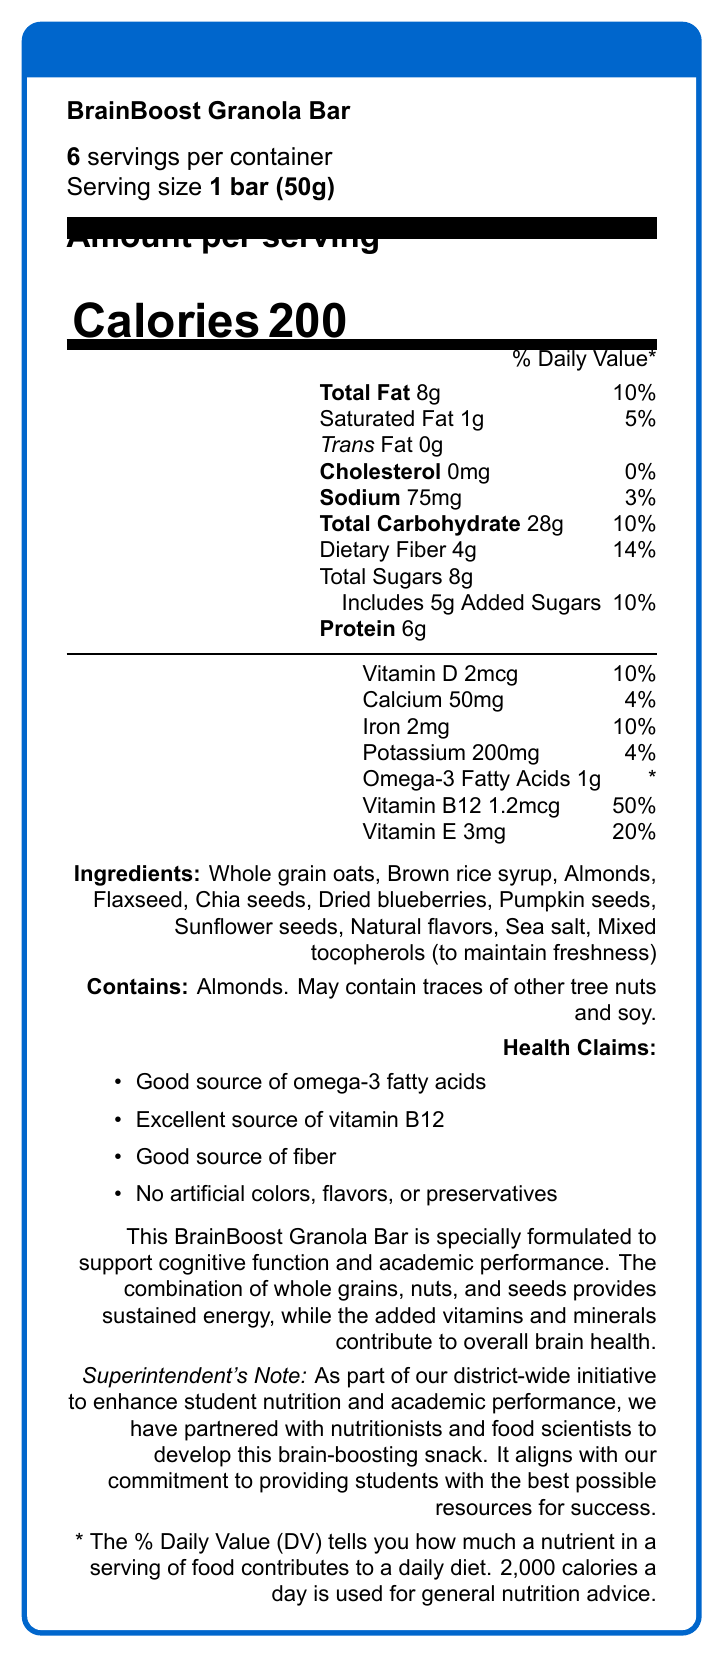What is the serving size for BrainBoost Granola Bar? The serving size is explicitly mentioned as "1 bar (50g)" in the document.
Answer: 1 bar (50g) How many calories are there per serving of the BrainBoost Granola Bar? The document clearly states that there are 200 calories per serving.
Answer: 200 What percentage of the Daily Value for vitamin B12 does one bar provide? The document lists Vitamin B12 as providing 50% of the Daily Value per serving.
Answer: 50% Does the BrainBoost Granola Bar contain any trans fat? The document states "Trans Fat 0g" indicating there is no trans fat in the bar.
Answer: No What ingredients are used in the BrainBoost Granola Bar? All ingredients are listed in the document under "Ingredients".
Answer: Whole grain oats, Brown rice syrup, Almonds, Flaxseed, Chia seeds, Dried blueberries, Pumpkin seeds, Sunflower seeds, Natural flavors, Sea salt, Mixed tocopherols (to maintain freshness) Which of the following is NOT an ingredient in the BrainBoost Granola Bar? A. Whole grain oats B. Honey C. Almonds D. Flaxseed The document lists the ingredients and honey is not included, while whole grain oats, almonds, and flaxseed are mentioned.
Answer: B. Honey What is the total amount of sugars in one serving of the BrainBoost Granola Bar? The document states that the total sugars per serving is 8g.
Answer: 8g True or False: The BrainBoost Granola Bar contains artificial colors. The document lists "No artificial colors, flavors, or preservatives" under health claims.
Answer: False Which nutrient has the highest % Daily Value in one serving of the BrainBoost Granola Bar? A. Vitamin D B. Iron C. Vitamin B12 D. Calcium According to the document, Vitamin B12 has a Daily Value of 50%, which is the highest among the listed nutrients.
Answer: C. Vitamin B12 How many servings are there in one container of BrainBoost Granola Bars? The document states that there are 6 servings per container.
Answer: 6 Explain the main purpose of the BrainBoost Granola Bar according to the document. The document describes the product as being specially formulated to support cognitive function and academic performance, highlighting its nutritional content and educational statement.
Answer: The BrainBoost Granola Bar is designed to support cognitive function and academic performance by providing sustained energy through whole grains, nuts, and seeds, along with added vitamins and minerals for overall brain health. What is the total fat content in one serving, and what percentage of the Daily Value does it represent? The document states that the total fat content is 8g per serving, which represents 10% of the Daily Value.
Answer: 8g, 10% What are the health claims associated with the BrainBoost Granola Bar? The health claims are listed under "Health Claims" in the document.
Answer: Good source of omega-3 fatty acids, Excellent source of vitamin B12, Good source of fiber, No artificial colors, flavors, or preservatives What are the educational benefits mentioned in the document for the BrainBoost Granola Bar? The document mentions that the BrainBoost Granola Bar is specially formulated to support cognitive function and academic performance.
Answer: Supports cognitive function and academic performance Which vitamin does the BrainBoost Granola Bar provide the least percentage of the Daily Value for? According to the document, Vitamin E provides 20% of the Daily Value, which is the lowest among the vitamins listed.
Answer: Vitamin E What is the total amount of dietary fiber in one serving of the BrainBoost Granola Bar? The document states that the total dietary fiber per serving is 4g.
Answer: 4g Does the document provide information about the price of the BrainBoost Granola Bar? The document does not include any details about the price of the BrainBoost Granola Bar, thus the information cannot be determined.
Answer: Not enough information 